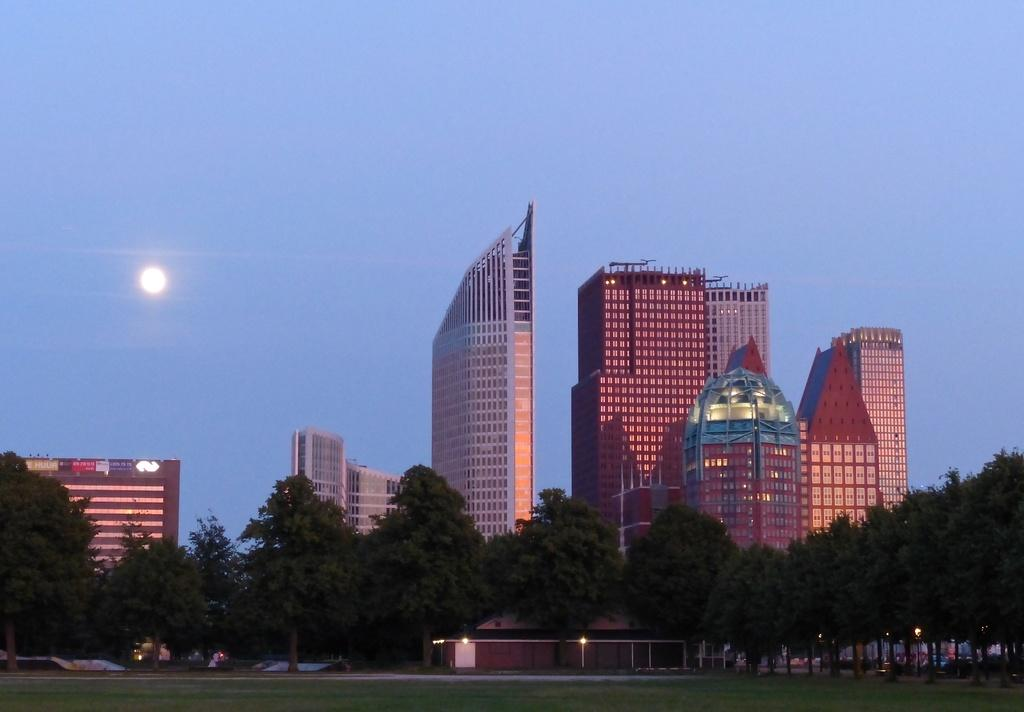What type of structures can be seen in the image? There are buildings in the image. What other natural elements are present in the image? There are trees and grass on the ground in the image. What can be seen in the sky in the image? The moon is visible in the sky, and the sky is blue. Are there any artificial light sources visible in the image? Yes, there are lights visible in the image. What type of acoustics can be heard in the image? There is no sound or acoustics present in the image, as it is a still photograph. How does the mind of the person who took the image affect the image? The image is a representation of the scene and does not reflect the mind of the person who took it. The image is an objective representation of the scene, and the photographer's mind does not directly affect the image. 